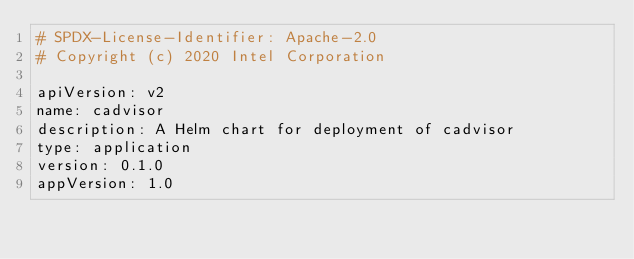<code> <loc_0><loc_0><loc_500><loc_500><_YAML_># SPDX-License-Identifier: Apache-2.0
# Copyright (c) 2020 Intel Corporation

apiVersion: v2
name: cadvisor
description: A Helm chart for deployment of cadvisor
type: application
version: 0.1.0
appVersion: 1.0
</code> 